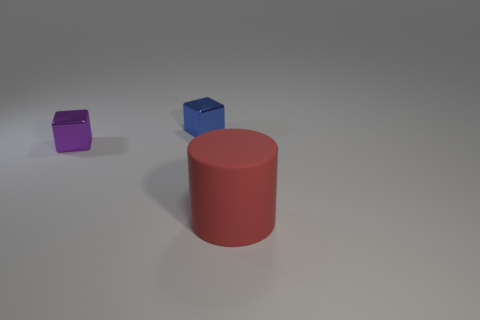What color is the metal thing that is in front of the shiny object right of the tiny metallic thing in front of the blue shiny thing? The metal object you're referring to appears to be a purple cube. It is positioned in front of a large, red cylindrical object, which is to the right of a smaller metallic item that is directly in front of a blue cube. 